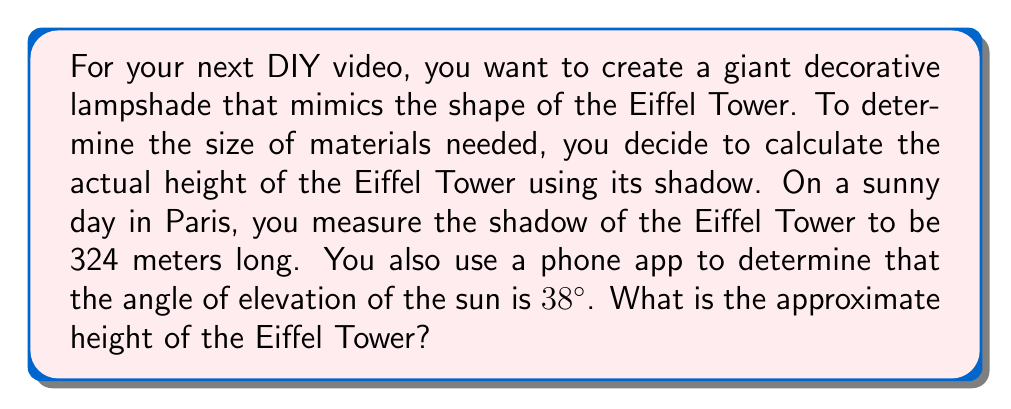Provide a solution to this math problem. Let's approach this step-by-step using trigonometry:

1) We can model this situation as a right triangle, where:
   - The shadow length is the base of the triangle
   - The height of the Eiffel Tower is the vertical side
   - The sun's rays form the hypotenuse

2) We know:
   - The shadow length (adjacent side) = 324 meters
   - The angle of elevation of the sun = 38°

3) We need to find the opposite side (height of the tower). The trigonometric ratio that relates the opposite side to the adjacent side is the tangent.

4) The formula we'll use is:

   $$\tan(\theta) = \frac{\text{opposite}}{\text{adjacent}}$$

   Where $\theta$ is the angle of elevation.

5) Substituting our known values:

   $$\tan(38°) = \frac{\text{height}}{324}$$

6) To solve for the height, we multiply both sides by 324:

   $$324 \cdot \tan(38°) = \text{height}$$

7) Using a calculator (or trigonometric tables):

   $$324 \cdot 0.7813 \approx 253.14$$

Therefore, the approximate height of the Eiffel Tower is 253.14 meters.

[asy]
import geometry;

size(200);
pair A = (0,0), B = (8,0), C = (0,6);
draw(A--B--C--A);
draw(rightanglemark(A,B,C,20));

label("324 m", (4,-0.5));
label("Height", (-0.5,3));
label("38°", (0.7,0.5));

dot("A", A, SW);
dot("B", B, SE);
dot("C", C, NW);
[/asy]
Answer: The approximate height of the Eiffel Tower is 253.14 meters. 